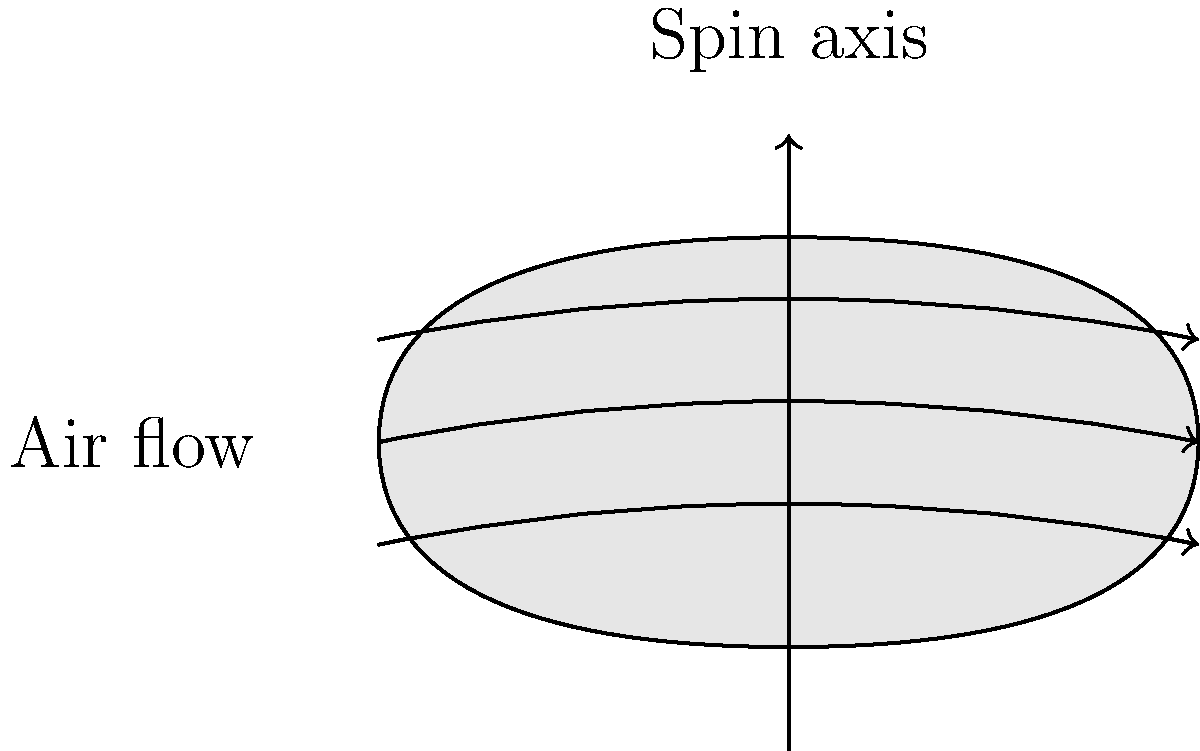As the head coach of the Arizona Cardinals, you're discussing the aerodynamics of a football with a sports journalist. Given that a football spins around its long axis during a spiral pass, how does this rotation affect its flight path, and what physical principle explains this phenomenon? To understand the aerodynamics of a spinning football, we need to consider the following steps:

1. Shape effect: The elongated shape of the football creates an asymmetrical airflow around it. This shape helps reduce air resistance compared to a spherical object.

2. Spin effect: When the football spins around its long axis (as shown in the diagram), it creates a difference in air pressure on opposite sides of the ball.

3. Magnus effect: This is the key principle at play. The spinning football drags air around it, creating a thin layer of rotating air.

4. Pressure difference: On one side of the ball, the spinning air moves in the same direction as the overall airflow, increasing its speed. On the opposite side, it moves against the airflow, decreasing its speed.

5. Bernoulli's principle: According to this principle, faster-moving air has lower pressure than slower-moving air.

6. Resulting force: The pressure difference creates a force perpendicular to both the direction of motion and the axis of rotation. This force is called the Magnus force.

7. Flight path alteration: For a football thrown with a clockwise spin (from the passer's perspective), the Magnus force will push the ball slightly to the right, causing it to curve.

8. Stability: The spin also helps stabilize the football's flight by creating a gyroscopic effect, maintaining its orientation and reducing wobble.

9. Optimal spin rate: There's an ideal spin rate that maximizes stability while minimizing the curved trajectory. Too little spin reduces stability, while too much spin can cause excessive curving.

Understanding these principles allows coaches and players to optimize passing techniques for accuracy and distance.
Answer: Magnus effect causes spinning football to curve slightly due to pressure differences in airflow. 